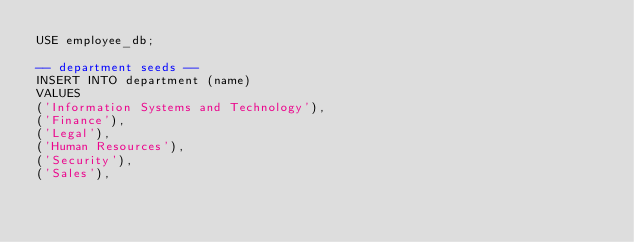<code> <loc_0><loc_0><loc_500><loc_500><_SQL_>USE employee_db;

-- department seeds --
INSERT INTO department (name)
VALUES
('Information Systems and Technology'),
('Finance'),
('Legal'),
('Human Resources'),
('Security'),
('Sales'),
</code> 